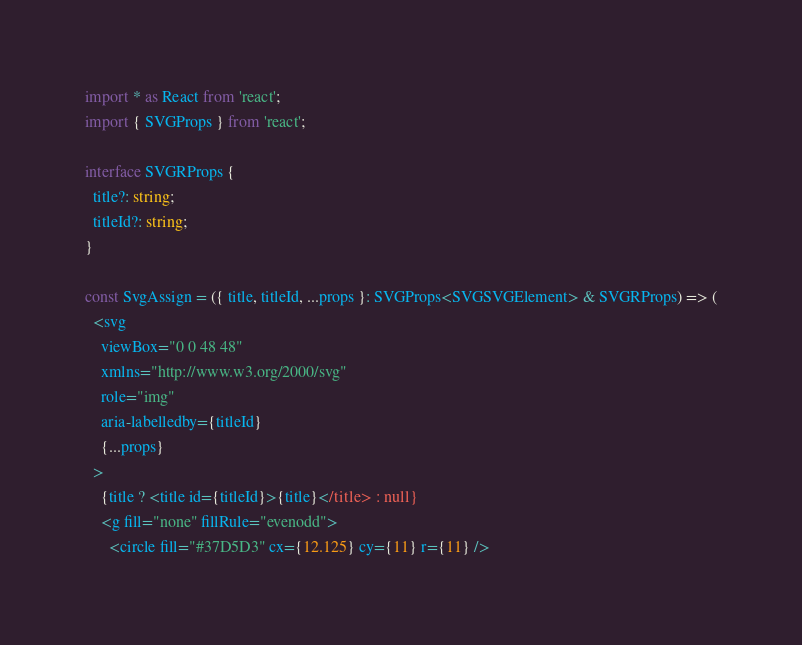Convert code to text. <code><loc_0><loc_0><loc_500><loc_500><_TypeScript_>import * as React from 'react';
import { SVGProps } from 'react';

interface SVGRProps {
  title?: string;
  titleId?: string;
}

const SvgAssign = ({ title, titleId, ...props }: SVGProps<SVGSVGElement> & SVGRProps) => (
  <svg
    viewBox="0 0 48 48"
    xmlns="http://www.w3.org/2000/svg"
    role="img"
    aria-labelledby={titleId}
    {...props}
  >
    {title ? <title id={titleId}>{title}</title> : null}
    <g fill="none" fillRule="evenodd">
      <circle fill="#37D5D3" cx={12.125} cy={11} r={11} /></code> 